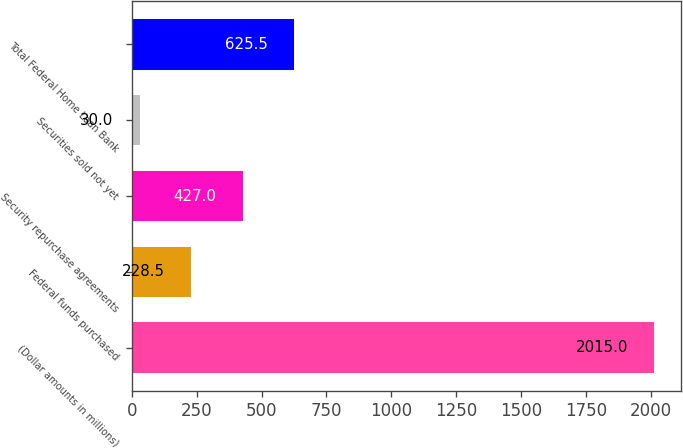Convert chart to OTSL. <chart><loc_0><loc_0><loc_500><loc_500><bar_chart><fcel>(Dollar amounts in millions)<fcel>Federal funds purchased<fcel>Security repurchase agreements<fcel>Securities sold not yet<fcel>Total Federal Home Loan Bank<nl><fcel>2015<fcel>228.5<fcel>427<fcel>30<fcel>625.5<nl></chart> 